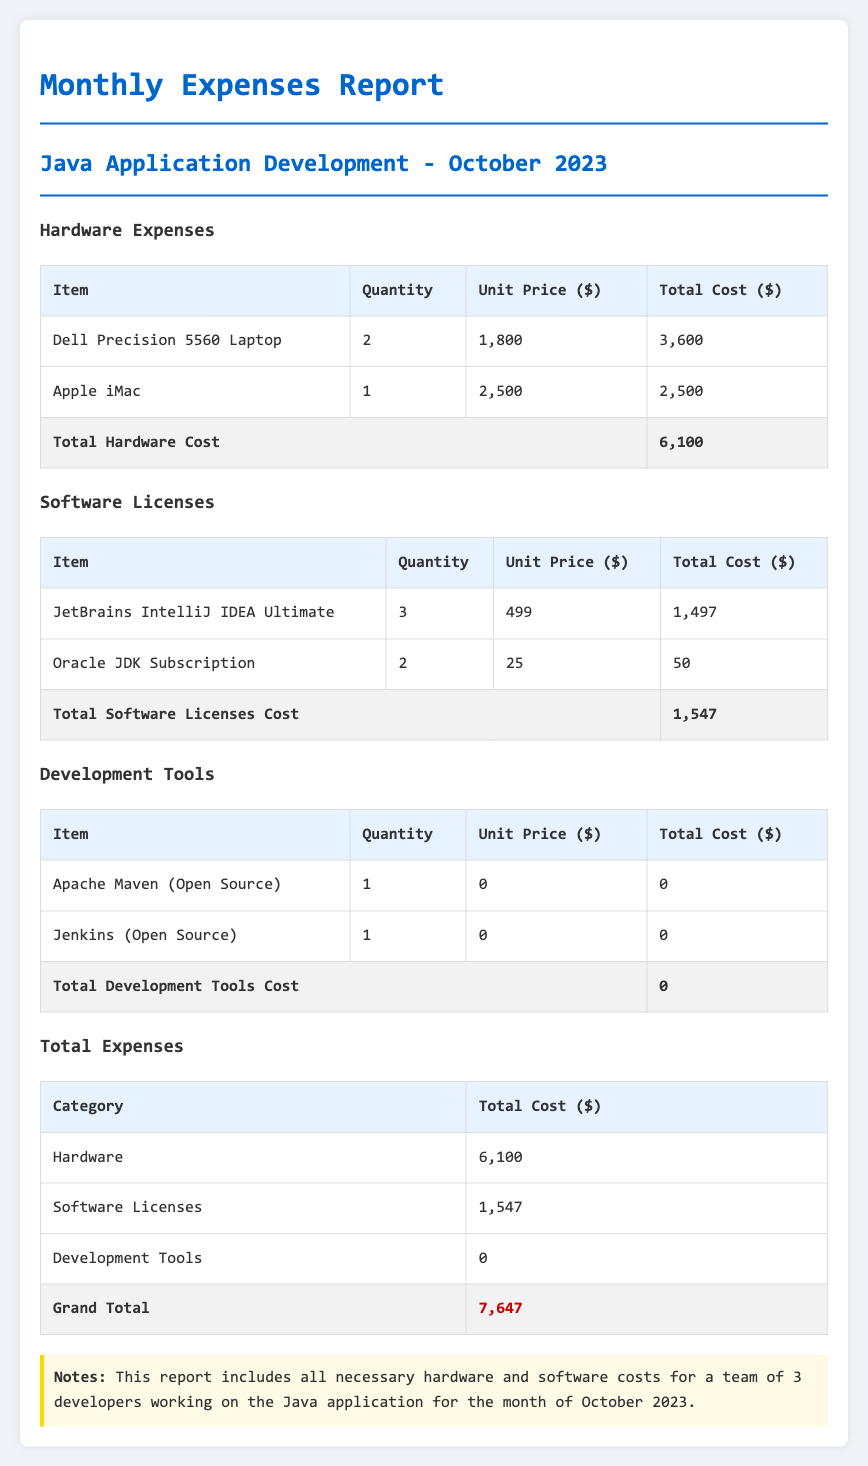What is the total cost of hardware? The total cost of hardware is presented in the total row under hardware expenses, which is $6,100.
Answer: $6,100 How many Dell Precision 5560 Laptops were purchased? The quantity of Dell Precision 5560 Laptops is listed in the hardware table, which is 2.
Answer: 2 What is the unit price of JetBrains IntelliJ IDEA Ultimate? The unit price of JetBrains IntelliJ IDEA Ultimate can be found in the software licenses table, which is $499.
Answer: $499 What is the grand total cost for all expenses? The grand total is shown in the total expenses table as the sum of hardware, software licenses, and development tools, which is $7,647.
Answer: $7,647 How many items are included in the software license section? The number of items in the software licenses section is determined by counting the entries in the table, which is 2.
Answer: 2 What is the total cost of development tools? The total cost of development tools can be seen in the development tools table, which is $0.
Answer: $0 What type of report is this document presenting? The document is presenting a monthly expenses report specifically for Java application development.
Answer: Monthly expenses report How many Apple iMacs were included in the hardware costs? The quantity of Apple iMacs is provided in the hardware table, which is 1.
Answer: 1 Is there any cost associated with development tools? The total cost for development tools is highlighted in the development tools section, which shows $0.
Answer: $0 